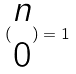<formula> <loc_0><loc_0><loc_500><loc_500>( \begin{matrix} n \\ 0 \end{matrix} ) = 1</formula> 